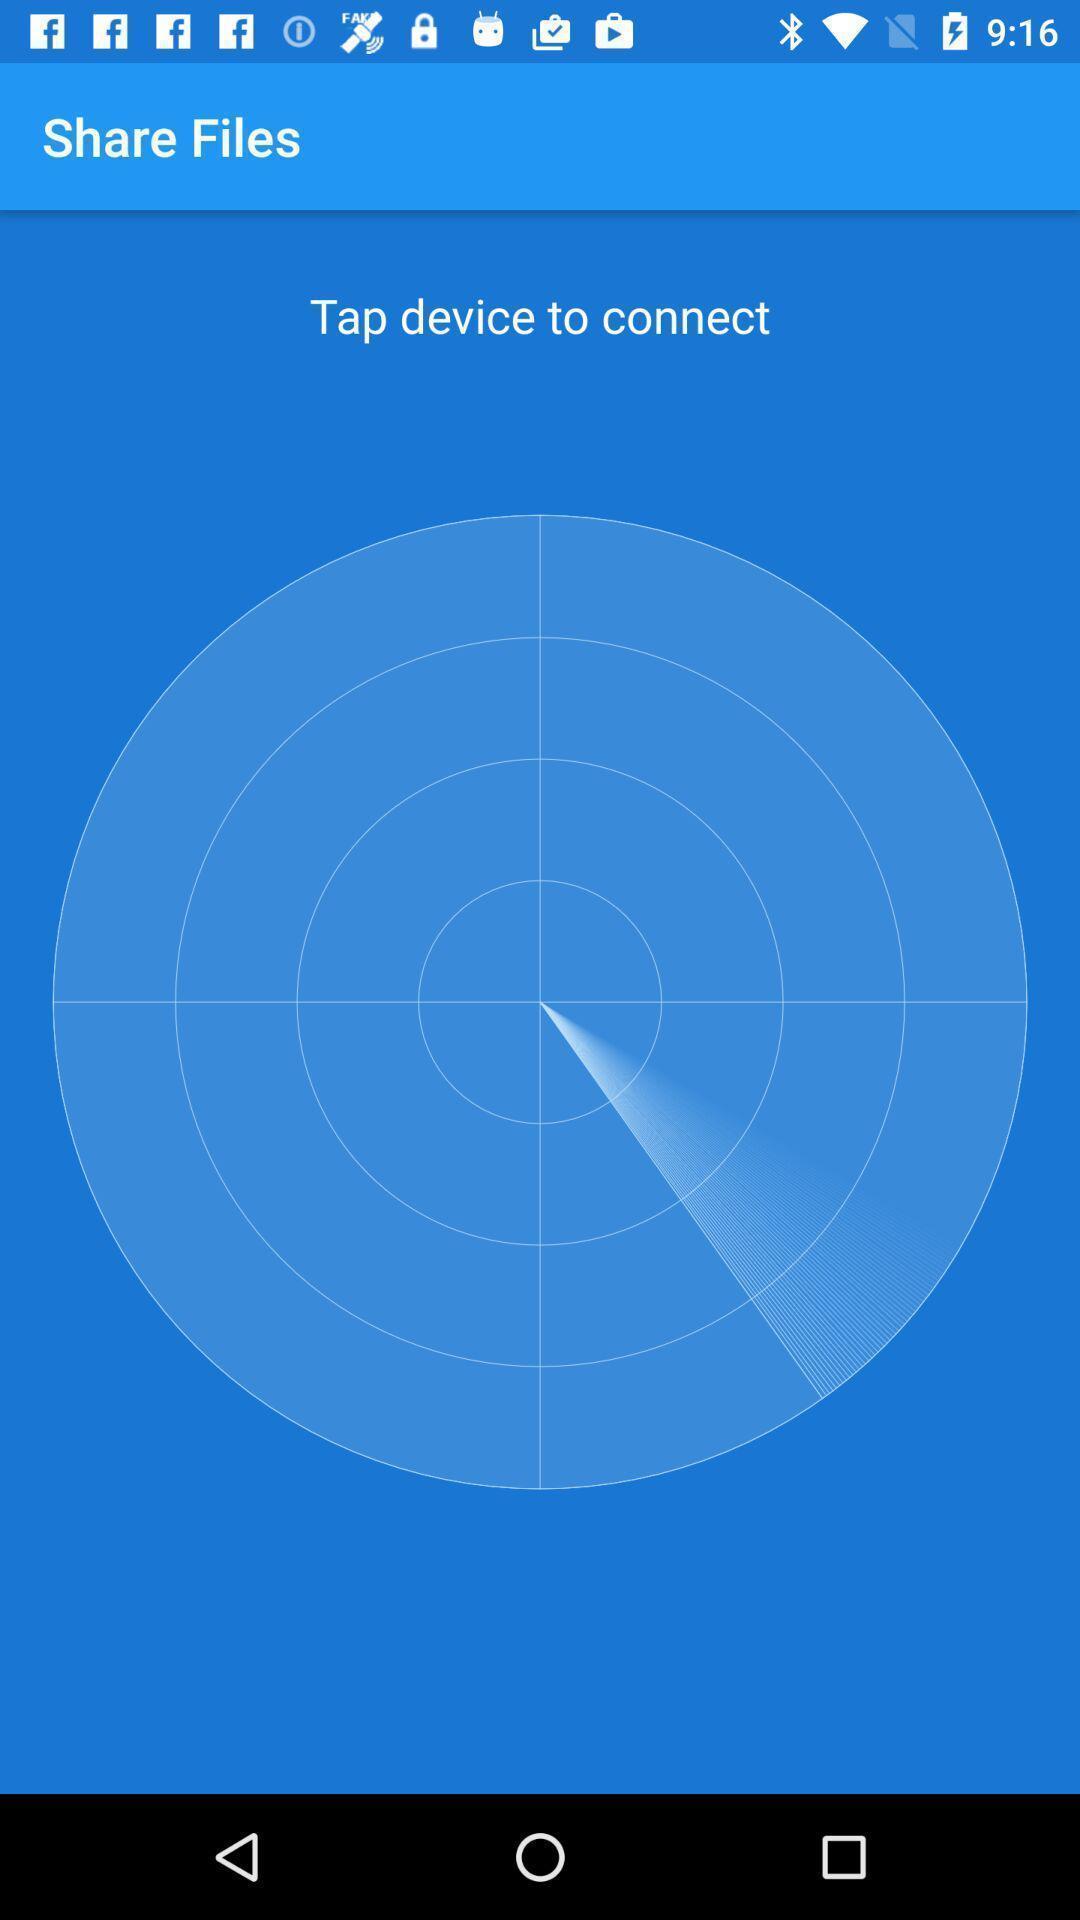Summarize the main components in this picture. Page displays to tap device to connect. 